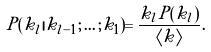<formula> <loc_0><loc_0><loc_500><loc_500>P ( k _ { l } | k _ { l - 1 } ; \dots ; k _ { 1 } ) = \frac { k _ { l } P ( k _ { l } ) } { \langle k \rangle } .</formula> 